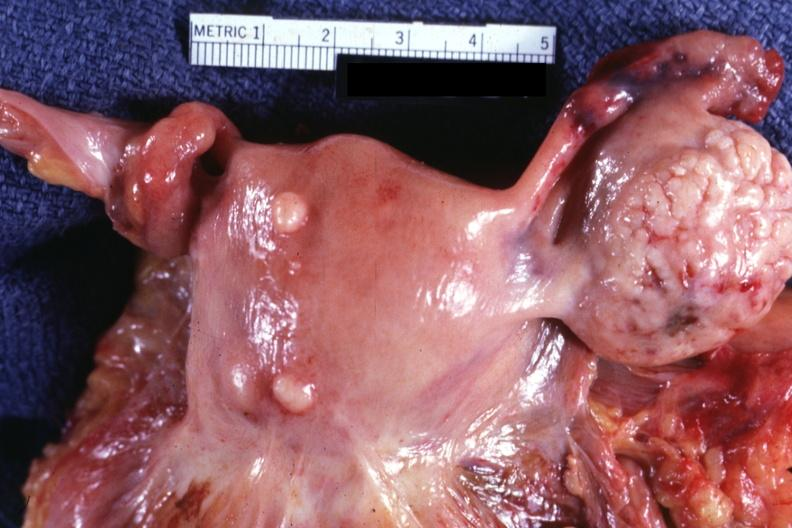s gangrene present?
Answer the question using a single word or phrase. No 